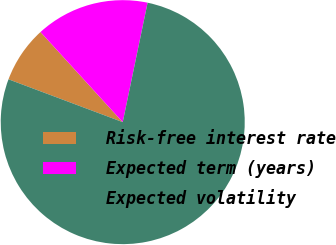<chart> <loc_0><loc_0><loc_500><loc_500><pie_chart><fcel>Risk-free interest rate<fcel>Expected term (years)<fcel>Expected volatility<nl><fcel>7.52%<fcel>15.04%<fcel>77.44%<nl></chart> 